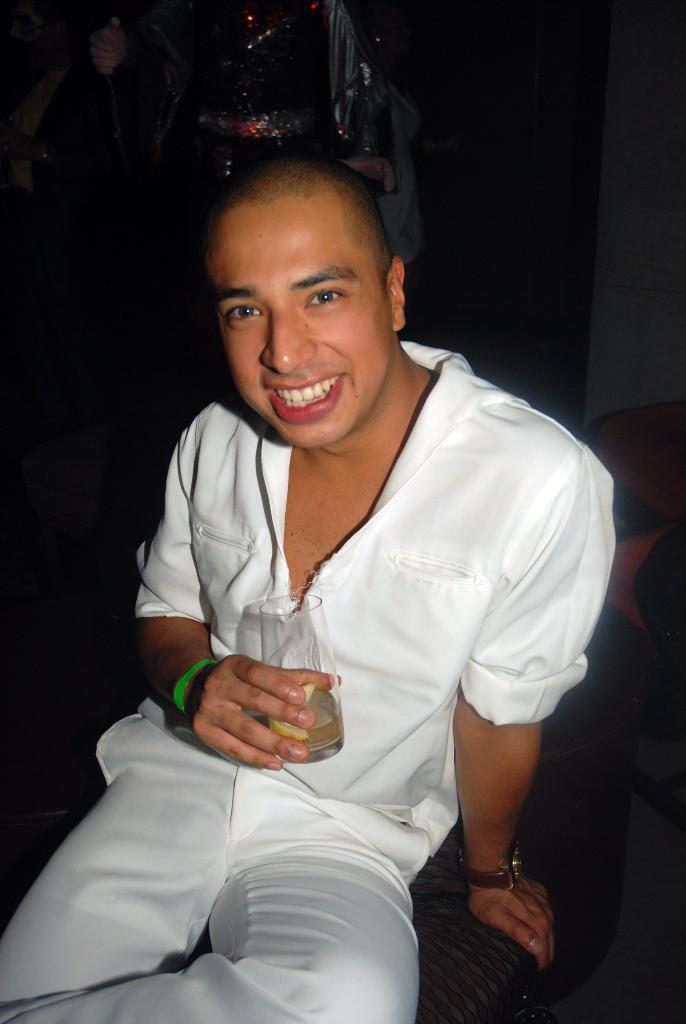Who can be seen in the image? There are people in the image. Can you describe the man in the image? There is a man in the middle of the image, and he is sitting. What is the man holding in the image? The man is holding a glass. What is the color of the background in the image? The background of the image is dark. What type of produce is being served on the sofa in the image? There is no produce or sofa present in the image. What color is the cream that the man is holding in the image? The man is holding a glass, not cream, in the image. 